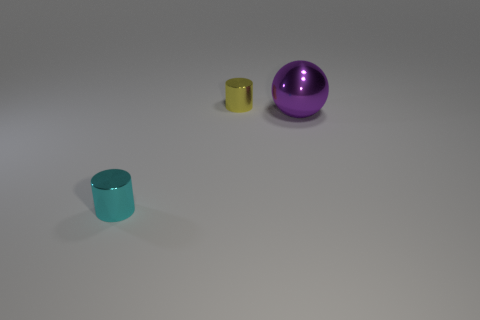There is a metallic object in front of the purple metal object in front of the yellow object; what is its color?
Offer a very short reply. Cyan. Is the color of the big thing the same as the small object that is in front of the big shiny ball?
Your answer should be compact. No. What is the material of the thing that is behind the small cyan cylinder and in front of the tiny yellow metal cylinder?
Your answer should be compact. Metal. Is there another purple ball of the same size as the purple shiny sphere?
Offer a very short reply. No. There is a yellow object that is the same size as the cyan shiny thing; what is it made of?
Your answer should be very brief. Metal. What number of small shiny cylinders are on the left side of the tiny yellow cylinder?
Keep it short and to the point. 1. Do the metallic object that is to the right of the tiny yellow object and the tiny cyan metallic thing have the same shape?
Provide a succinct answer. No. Are there any big purple rubber things of the same shape as the cyan metal thing?
Your answer should be very brief. No. There is a small metallic object that is left of the small object that is to the right of the cyan object; what shape is it?
Make the answer very short. Cylinder. What number of other yellow objects are the same material as the tiny yellow thing?
Your response must be concise. 0. 